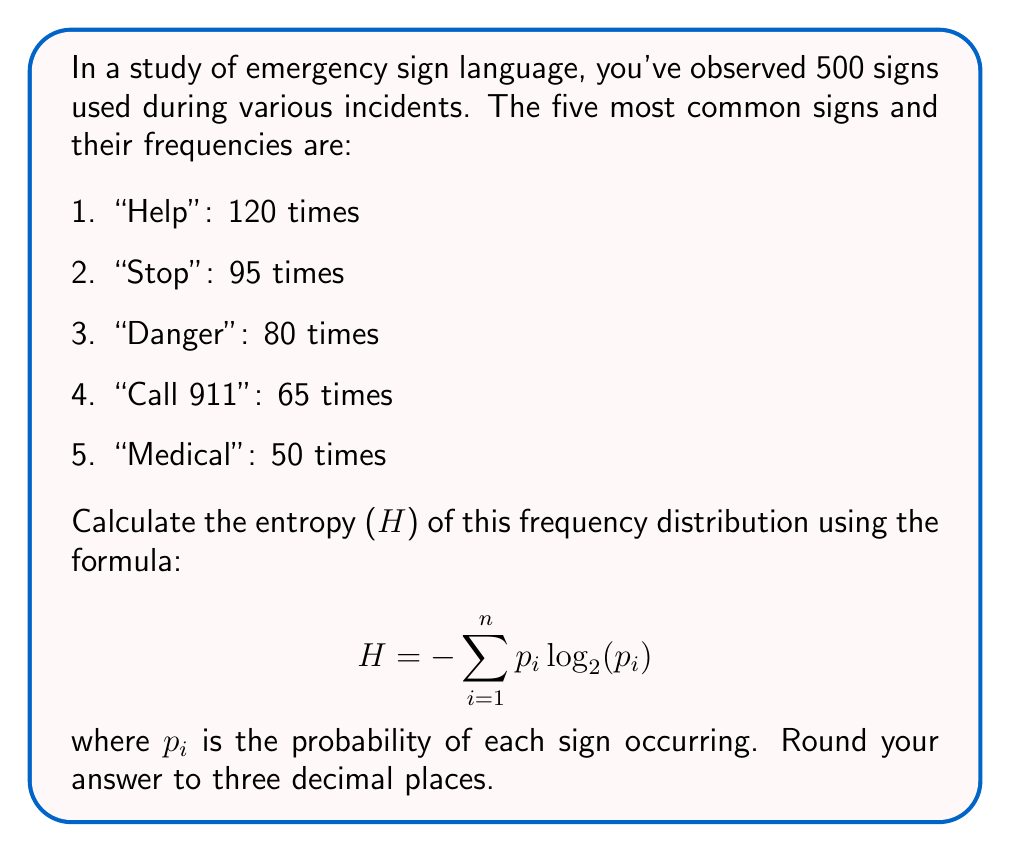Can you answer this question? To calculate the entropy, we need to follow these steps:

1. Calculate the total number of occurrences of these five signs:
   $120 + 95 + 80 + 65 + 50 = 410$

2. Calculate the probability ($p_i$) of each sign:
   $p_1 = 120/410 = 0.2927$
   $p_2 = 95/410 = 0.2317$
   $p_3 = 80/410 = 0.1951$
   $p_4 = 65/410 = 0.1585$
   $p_5 = 50/410 = 0.1220$

3. Calculate $-p_i \log_2(p_i)$ for each sign:
   $-0.2927 \log_2(0.2927) = 0.5199$
   $-0.2317 \log_2(0.2317) = 0.4894$
   $-0.1951 \log_2(0.1951) = 0.4585$
   $-0.1585 \log_2(0.1585) = 0.4209$
   $-0.1220 \log_2(0.1220) = 0.3681$

4. Sum all the values:
   $0.5199 + 0.4894 + 0.4585 + 0.4209 + 0.3681 = 2.2568$

5. Round to three decimal places:
   $2.257$
Answer: 2.257 